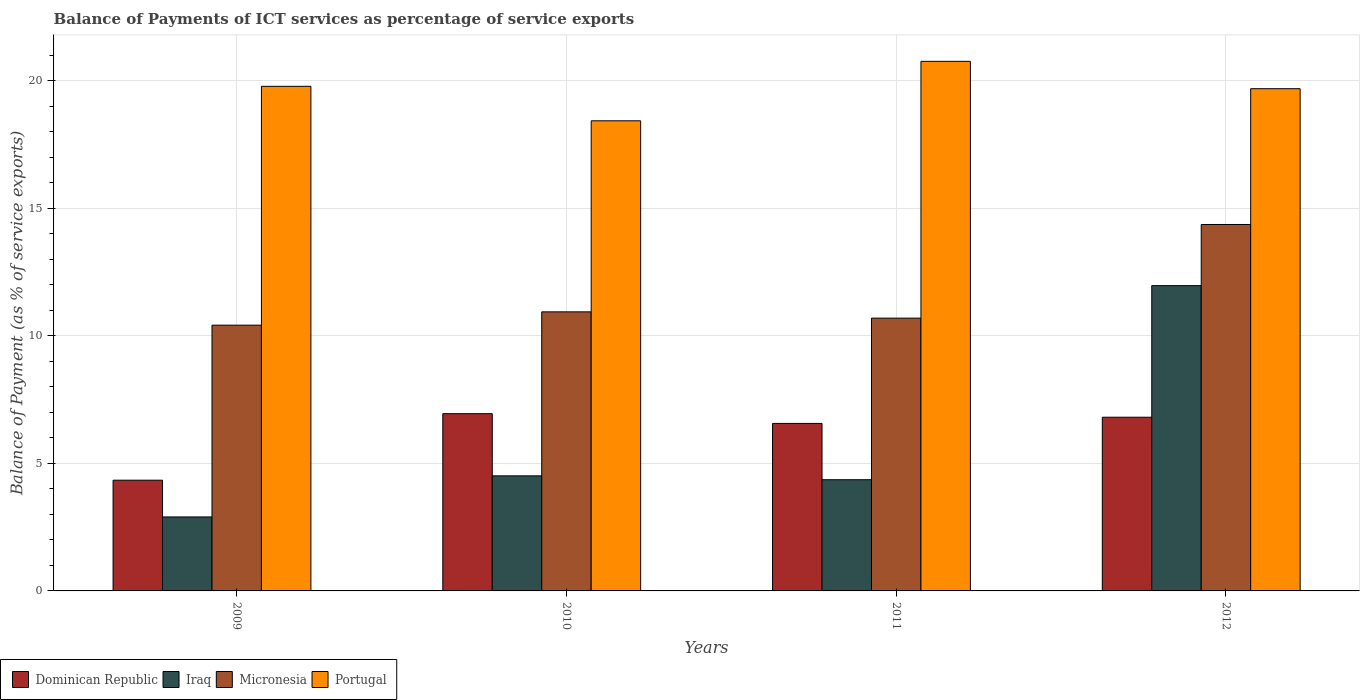How many groups of bars are there?
Offer a terse response. 4. How many bars are there on the 1st tick from the right?
Your answer should be very brief. 4. What is the label of the 4th group of bars from the left?
Make the answer very short. 2012. In how many cases, is the number of bars for a given year not equal to the number of legend labels?
Your response must be concise. 0. What is the balance of payments of ICT services in Iraq in 2012?
Provide a short and direct response. 11.97. Across all years, what is the maximum balance of payments of ICT services in Portugal?
Offer a terse response. 20.76. Across all years, what is the minimum balance of payments of ICT services in Dominican Republic?
Provide a short and direct response. 4.34. In which year was the balance of payments of ICT services in Portugal maximum?
Your response must be concise. 2011. In which year was the balance of payments of ICT services in Micronesia minimum?
Offer a very short reply. 2009. What is the total balance of payments of ICT services in Portugal in the graph?
Your answer should be very brief. 78.65. What is the difference between the balance of payments of ICT services in Portugal in 2009 and that in 2012?
Make the answer very short. 0.09. What is the difference between the balance of payments of ICT services in Micronesia in 2011 and the balance of payments of ICT services in Dominican Republic in 2009?
Provide a succinct answer. 6.35. What is the average balance of payments of ICT services in Portugal per year?
Give a very brief answer. 19.66. In the year 2009, what is the difference between the balance of payments of ICT services in Dominican Republic and balance of payments of ICT services in Portugal?
Offer a very short reply. -15.44. What is the ratio of the balance of payments of ICT services in Dominican Republic in 2009 to that in 2010?
Ensure brevity in your answer.  0.62. Is the difference between the balance of payments of ICT services in Dominican Republic in 2009 and 2012 greater than the difference between the balance of payments of ICT services in Portugal in 2009 and 2012?
Your answer should be very brief. No. What is the difference between the highest and the second highest balance of payments of ICT services in Portugal?
Your answer should be compact. 0.98. What is the difference between the highest and the lowest balance of payments of ICT services in Iraq?
Give a very brief answer. 9.07. In how many years, is the balance of payments of ICT services in Dominican Republic greater than the average balance of payments of ICT services in Dominican Republic taken over all years?
Keep it short and to the point. 3. Is it the case that in every year, the sum of the balance of payments of ICT services in Portugal and balance of payments of ICT services in Dominican Republic is greater than the sum of balance of payments of ICT services in Micronesia and balance of payments of ICT services in Iraq?
Provide a short and direct response. No. What does the 3rd bar from the left in 2011 represents?
Provide a short and direct response. Micronesia. What does the 2nd bar from the right in 2009 represents?
Provide a succinct answer. Micronesia. Is it the case that in every year, the sum of the balance of payments of ICT services in Portugal and balance of payments of ICT services in Dominican Republic is greater than the balance of payments of ICT services in Micronesia?
Offer a very short reply. Yes. How many years are there in the graph?
Provide a short and direct response. 4. Does the graph contain any zero values?
Make the answer very short. No. What is the title of the graph?
Offer a terse response. Balance of Payments of ICT services as percentage of service exports. What is the label or title of the Y-axis?
Provide a succinct answer. Balance of Payment (as % of service exports). What is the Balance of Payment (as % of service exports) of Dominican Republic in 2009?
Your answer should be very brief. 4.34. What is the Balance of Payment (as % of service exports) in Iraq in 2009?
Provide a succinct answer. 2.9. What is the Balance of Payment (as % of service exports) of Micronesia in 2009?
Offer a very short reply. 10.42. What is the Balance of Payment (as % of service exports) in Portugal in 2009?
Your response must be concise. 19.78. What is the Balance of Payment (as % of service exports) in Dominican Republic in 2010?
Your response must be concise. 6.95. What is the Balance of Payment (as % of service exports) of Iraq in 2010?
Your answer should be very brief. 4.51. What is the Balance of Payment (as % of service exports) in Micronesia in 2010?
Make the answer very short. 10.94. What is the Balance of Payment (as % of service exports) in Portugal in 2010?
Offer a very short reply. 18.43. What is the Balance of Payment (as % of service exports) in Dominican Republic in 2011?
Your answer should be very brief. 6.57. What is the Balance of Payment (as % of service exports) in Iraq in 2011?
Make the answer very short. 4.36. What is the Balance of Payment (as % of service exports) of Micronesia in 2011?
Ensure brevity in your answer.  10.69. What is the Balance of Payment (as % of service exports) of Portugal in 2011?
Make the answer very short. 20.76. What is the Balance of Payment (as % of service exports) of Dominican Republic in 2012?
Keep it short and to the point. 6.81. What is the Balance of Payment (as % of service exports) of Iraq in 2012?
Offer a terse response. 11.97. What is the Balance of Payment (as % of service exports) of Micronesia in 2012?
Provide a succinct answer. 14.36. What is the Balance of Payment (as % of service exports) of Portugal in 2012?
Keep it short and to the point. 19.68. Across all years, what is the maximum Balance of Payment (as % of service exports) in Dominican Republic?
Your answer should be compact. 6.95. Across all years, what is the maximum Balance of Payment (as % of service exports) in Iraq?
Your response must be concise. 11.97. Across all years, what is the maximum Balance of Payment (as % of service exports) in Micronesia?
Ensure brevity in your answer.  14.36. Across all years, what is the maximum Balance of Payment (as % of service exports) of Portugal?
Give a very brief answer. 20.76. Across all years, what is the minimum Balance of Payment (as % of service exports) in Dominican Republic?
Ensure brevity in your answer.  4.34. Across all years, what is the minimum Balance of Payment (as % of service exports) in Iraq?
Your response must be concise. 2.9. Across all years, what is the minimum Balance of Payment (as % of service exports) of Micronesia?
Offer a terse response. 10.42. Across all years, what is the minimum Balance of Payment (as % of service exports) in Portugal?
Provide a short and direct response. 18.43. What is the total Balance of Payment (as % of service exports) of Dominican Republic in the graph?
Offer a very short reply. 24.66. What is the total Balance of Payment (as % of service exports) of Iraq in the graph?
Offer a very short reply. 23.73. What is the total Balance of Payment (as % of service exports) in Micronesia in the graph?
Keep it short and to the point. 46.41. What is the total Balance of Payment (as % of service exports) of Portugal in the graph?
Your answer should be compact. 78.65. What is the difference between the Balance of Payment (as % of service exports) in Dominican Republic in 2009 and that in 2010?
Your answer should be compact. -2.61. What is the difference between the Balance of Payment (as % of service exports) in Iraq in 2009 and that in 2010?
Your answer should be compact. -1.61. What is the difference between the Balance of Payment (as % of service exports) in Micronesia in 2009 and that in 2010?
Provide a short and direct response. -0.52. What is the difference between the Balance of Payment (as % of service exports) of Portugal in 2009 and that in 2010?
Your answer should be compact. 1.35. What is the difference between the Balance of Payment (as % of service exports) of Dominican Republic in 2009 and that in 2011?
Your answer should be compact. -2.23. What is the difference between the Balance of Payment (as % of service exports) in Iraq in 2009 and that in 2011?
Your response must be concise. -1.46. What is the difference between the Balance of Payment (as % of service exports) in Micronesia in 2009 and that in 2011?
Give a very brief answer. -0.28. What is the difference between the Balance of Payment (as % of service exports) in Portugal in 2009 and that in 2011?
Your response must be concise. -0.98. What is the difference between the Balance of Payment (as % of service exports) in Dominican Republic in 2009 and that in 2012?
Ensure brevity in your answer.  -2.47. What is the difference between the Balance of Payment (as % of service exports) in Iraq in 2009 and that in 2012?
Give a very brief answer. -9.07. What is the difference between the Balance of Payment (as % of service exports) of Micronesia in 2009 and that in 2012?
Provide a short and direct response. -3.95. What is the difference between the Balance of Payment (as % of service exports) of Portugal in 2009 and that in 2012?
Offer a very short reply. 0.09. What is the difference between the Balance of Payment (as % of service exports) of Dominican Republic in 2010 and that in 2011?
Provide a short and direct response. 0.38. What is the difference between the Balance of Payment (as % of service exports) in Iraq in 2010 and that in 2011?
Provide a short and direct response. 0.15. What is the difference between the Balance of Payment (as % of service exports) in Micronesia in 2010 and that in 2011?
Offer a very short reply. 0.25. What is the difference between the Balance of Payment (as % of service exports) in Portugal in 2010 and that in 2011?
Provide a short and direct response. -2.33. What is the difference between the Balance of Payment (as % of service exports) of Dominican Republic in 2010 and that in 2012?
Keep it short and to the point. 0.14. What is the difference between the Balance of Payment (as % of service exports) in Iraq in 2010 and that in 2012?
Provide a succinct answer. -7.46. What is the difference between the Balance of Payment (as % of service exports) of Micronesia in 2010 and that in 2012?
Keep it short and to the point. -3.42. What is the difference between the Balance of Payment (as % of service exports) of Portugal in 2010 and that in 2012?
Offer a terse response. -1.26. What is the difference between the Balance of Payment (as % of service exports) of Dominican Republic in 2011 and that in 2012?
Give a very brief answer. -0.24. What is the difference between the Balance of Payment (as % of service exports) in Iraq in 2011 and that in 2012?
Make the answer very short. -7.61. What is the difference between the Balance of Payment (as % of service exports) in Micronesia in 2011 and that in 2012?
Offer a terse response. -3.67. What is the difference between the Balance of Payment (as % of service exports) in Portugal in 2011 and that in 2012?
Provide a short and direct response. 1.07. What is the difference between the Balance of Payment (as % of service exports) in Dominican Republic in 2009 and the Balance of Payment (as % of service exports) in Iraq in 2010?
Keep it short and to the point. -0.17. What is the difference between the Balance of Payment (as % of service exports) of Dominican Republic in 2009 and the Balance of Payment (as % of service exports) of Micronesia in 2010?
Provide a succinct answer. -6.6. What is the difference between the Balance of Payment (as % of service exports) of Dominican Republic in 2009 and the Balance of Payment (as % of service exports) of Portugal in 2010?
Your response must be concise. -14.09. What is the difference between the Balance of Payment (as % of service exports) in Iraq in 2009 and the Balance of Payment (as % of service exports) in Micronesia in 2010?
Offer a very short reply. -8.04. What is the difference between the Balance of Payment (as % of service exports) in Iraq in 2009 and the Balance of Payment (as % of service exports) in Portugal in 2010?
Ensure brevity in your answer.  -15.53. What is the difference between the Balance of Payment (as % of service exports) of Micronesia in 2009 and the Balance of Payment (as % of service exports) of Portugal in 2010?
Provide a succinct answer. -8.01. What is the difference between the Balance of Payment (as % of service exports) in Dominican Republic in 2009 and the Balance of Payment (as % of service exports) in Iraq in 2011?
Provide a short and direct response. -0.02. What is the difference between the Balance of Payment (as % of service exports) in Dominican Republic in 2009 and the Balance of Payment (as % of service exports) in Micronesia in 2011?
Offer a terse response. -6.35. What is the difference between the Balance of Payment (as % of service exports) of Dominican Republic in 2009 and the Balance of Payment (as % of service exports) of Portugal in 2011?
Your response must be concise. -16.42. What is the difference between the Balance of Payment (as % of service exports) of Iraq in 2009 and the Balance of Payment (as % of service exports) of Micronesia in 2011?
Your response must be concise. -7.79. What is the difference between the Balance of Payment (as % of service exports) in Iraq in 2009 and the Balance of Payment (as % of service exports) in Portugal in 2011?
Your response must be concise. -17.86. What is the difference between the Balance of Payment (as % of service exports) of Micronesia in 2009 and the Balance of Payment (as % of service exports) of Portugal in 2011?
Provide a succinct answer. -10.34. What is the difference between the Balance of Payment (as % of service exports) of Dominican Republic in 2009 and the Balance of Payment (as % of service exports) of Iraq in 2012?
Your answer should be compact. -7.63. What is the difference between the Balance of Payment (as % of service exports) of Dominican Republic in 2009 and the Balance of Payment (as % of service exports) of Micronesia in 2012?
Offer a terse response. -10.02. What is the difference between the Balance of Payment (as % of service exports) of Dominican Republic in 2009 and the Balance of Payment (as % of service exports) of Portugal in 2012?
Make the answer very short. -15.34. What is the difference between the Balance of Payment (as % of service exports) of Iraq in 2009 and the Balance of Payment (as % of service exports) of Micronesia in 2012?
Your answer should be very brief. -11.46. What is the difference between the Balance of Payment (as % of service exports) in Iraq in 2009 and the Balance of Payment (as % of service exports) in Portugal in 2012?
Your answer should be very brief. -16.79. What is the difference between the Balance of Payment (as % of service exports) of Micronesia in 2009 and the Balance of Payment (as % of service exports) of Portugal in 2012?
Give a very brief answer. -9.27. What is the difference between the Balance of Payment (as % of service exports) in Dominican Republic in 2010 and the Balance of Payment (as % of service exports) in Iraq in 2011?
Offer a terse response. 2.59. What is the difference between the Balance of Payment (as % of service exports) of Dominican Republic in 2010 and the Balance of Payment (as % of service exports) of Micronesia in 2011?
Your answer should be compact. -3.74. What is the difference between the Balance of Payment (as % of service exports) of Dominican Republic in 2010 and the Balance of Payment (as % of service exports) of Portugal in 2011?
Your answer should be very brief. -13.81. What is the difference between the Balance of Payment (as % of service exports) of Iraq in 2010 and the Balance of Payment (as % of service exports) of Micronesia in 2011?
Provide a succinct answer. -6.18. What is the difference between the Balance of Payment (as % of service exports) in Iraq in 2010 and the Balance of Payment (as % of service exports) in Portugal in 2011?
Ensure brevity in your answer.  -16.25. What is the difference between the Balance of Payment (as % of service exports) in Micronesia in 2010 and the Balance of Payment (as % of service exports) in Portugal in 2011?
Your answer should be compact. -9.82. What is the difference between the Balance of Payment (as % of service exports) of Dominican Republic in 2010 and the Balance of Payment (as % of service exports) of Iraq in 2012?
Offer a terse response. -5.02. What is the difference between the Balance of Payment (as % of service exports) in Dominican Republic in 2010 and the Balance of Payment (as % of service exports) in Micronesia in 2012?
Your response must be concise. -7.42. What is the difference between the Balance of Payment (as % of service exports) in Dominican Republic in 2010 and the Balance of Payment (as % of service exports) in Portugal in 2012?
Your answer should be very brief. -12.74. What is the difference between the Balance of Payment (as % of service exports) of Iraq in 2010 and the Balance of Payment (as % of service exports) of Micronesia in 2012?
Your response must be concise. -9.85. What is the difference between the Balance of Payment (as % of service exports) in Iraq in 2010 and the Balance of Payment (as % of service exports) in Portugal in 2012?
Your answer should be very brief. -15.17. What is the difference between the Balance of Payment (as % of service exports) in Micronesia in 2010 and the Balance of Payment (as % of service exports) in Portugal in 2012?
Provide a short and direct response. -8.75. What is the difference between the Balance of Payment (as % of service exports) in Dominican Republic in 2011 and the Balance of Payment (as % of service exports) in Iraq in 2012?
Offer a terse response. -5.4. What is the difference between the Balance of Payment (as % of service exports) of Dominican Republic in 2011 and the Balance of Payment (as % of service exports) of Micronesia in 2012?
Offer a very short reply. -7.8. What is the difference between the Balance of Payment (as % of service exports) of Dominican Republic in 2011 and the Balance of Payment (as % of service exports) of Portugal in 2012?
Your response must be concise. -13.12. What is the difference between the Balance of Payment (as % of service exports) of Iraq in 2011 and the Balance of Payment (as % of service exports) of Micronesia in 2012?
Your answer should be very brief. -10. What is the difference between the Balance of Payment (as % of service exports) in Iraq in 2011 and the Balance of Payment (as % of service exports) in Portugal in 2012?
Provide a succinct answer. -15.33. What is the difference between the Balance of Payment (as % of service exports) in Micronesia in 2011 and the Balance of Payment (as % of service exports) in Portugal in 2012?
Make the answer very short. -8.99. What is the average Balance of Payment (as % of service exports) of Dominican Republic per year?
Provide a succinct answer. 6.17. What is the average Balance of Payment (as % of service exports) of Iraq per year?
Your answer should be very brief. 5.93. What is the average Balance of Payment (as % of service exports) of Micronesia per year?
Offer a very short reply. 11.6. What is the average Balance of Payment (as % of service exports) in Portugal per year?
Provide a short and direct response. 19.66. In the year 2009, what is the difference between the Balance of Payment (as % of service exports) in Dominican Republic and Balance of Payment (as % of service exports) in Iraq?
Keep it short and to the point. 1.44. In the year 2009, what is the difference between the Balance of Payment (as % of service exports) of Dominican Republic and Balance of Payment (as % of service exports) of Micronesia?
Make the answer very short. -6.08. In the year 2009, what is the difference between the Balance of Payment (as % of service exports) in Dominican Republic and Balance of Payment (as % of service exports) in Portugal?
Give a very brief answer. -15.44. In the year 2009, what is the difference between the Balance of Payment (as % of service exports) of Iraq and Balance of Payment (as % of service exports) of Micronesia?
Ensure brevity in your answer.  -7.52. In the year 2009, what is the difference between the Balance of Payment (as % of service exports) of Iraq and Balance of Payment (as % of service exports) of Portugal?
Give a very brief answer. -16.88. In the year 2009, what is the difference between the Balance of Payment (as % of service exports) of Micronesia and Balance of Payment (as % of service exports) of Portugal?
Ensure brevity in your answer.  -9.36. In the year 2010, what is the difference between the Balance of Payment (as % of service exports) in Dominican Republic and Balance of Payment (as % of service exports) in Iraq?
Provide a succinct answer. 2.44. In the year 2010, what is the difference between the Balance of Payment (as % of service exports) of Dominican Republic and Balance of Payment (as % of service exports) of Micronesia?
Make the answer very short. -3.99. In the year 2010, what is the difference between the Balance of Payment (as % of service exports) of Dominican Republic and Balance of Payment (as % of service exports) of Portugal?
Offer a very short reply. -11.48. In the year 2010, what is the difference between the Balance of Payment (as % of service exports) of Iraq and Balance of Payment (as % of service exports) of Micronesia?
Your answer should be compact. -6.43. In the year 2010, what is the difference between the Balance of Payment (as % of service exports) of Iraq and Balance of Payment (as % of service exports) of Portugal?
Your answer should be compact. -13.92. In the year 2010, what is the difference between the Balance of Payment (as % of service exports) in Micronesia and Balance of Payment (as % of service exports) in Portugal?
Give a very brief answer. -7.49. In the year 2011, what is the difference between the Balance of Payment (as % of service exports) in Dominican Republic and Balance of Payment (as % of service exports) in Iraq?
Make the answer very short. 2.21. In the year 2011, what is the difference between the Balance of Payment (as % of service exports) of Dominican Republic and Balance of Payment (as % of service exports) of Micronesia?
Provide a succinct answer. -4.13. In the year 2011, what is the difference between the Balance of Payment (as % of service exports) in Dominican Republic and Balance of Payment (as % of service exports) in Portugal?
Ensure brevity in your answer.  -14.19. In the year 2011, what is the difference between the Balance of Payment (as % of service exports) of Iraq and Balance of Payment (as % of service exports) of Micronesia?
Offer a very short reply. -6.33. In the year 2011, what is the difference between the Balance of Payment (as % of service exports) of Iraq and Balance of Payment (as % of service exports) of Portugal?
Give a very brief answer. -16.4. In the year 2011, what is the difference between the Balance of Payment (as % of service exports) in Micronesia and Balance of Payment (as % of service exports) in Portugal?
Your response must be concise. -10.06. In the year 2012, what is the difference between the Balance of Payment (as % of service exports) in Dominican Republic and Balance of Payment (as % of service exports) in Iraq?
Make the answer very short. -5.16. In the year 2012, what is the difference between the Balance of Payment (as % of service exports) in Dominican Republic and Balance of Payment (as % of service exports) in Micronesia?
Your answer should be very brief. -7.55. In the year 2012, what is the difference between the Balance of Payment (as % of service exports) of Dominican Republic and Balance of Payment (as % of service exports) of Portugal?
Your answer should be compact. -12.88. In the year 2012, what is the difference between the Balance of Payment (as % of service exports) of Iraq and Balance of Payment (as % of service exports) of Micronesia?
Provide a short and direct response. -2.4. In the year 2012, what is the difference between the Balance of Payment (as % of service exports) in Iraq and Balance of Payment (as % of service exports) in Portugal?
Ensure brevity in your answer.  -7.72. In the year 2012, what is the difference between the Balance of Payment (as % of service exports) of Micronesia and Balance of Payment (as % of service exports) of Portugal?
Your answer should be compact. -5.32. What is the ratio of the Balance of Payment (as % of service exports) in Dominican Republic in 2009 to that in 2010?
Your answer should be compact. 0.62. What is the ratio of the Balance of Payment (as % of service exports) in Iraq in 2009 to that in 2010?
Your response must be concise. 0.64. What is the ratio of the Balance of Payment (as % of service exports) of Micronesia in 2009 to that in 2010?
Your answer should be very brief. 0.95. What is the ratio of the Balance of Payment (as % of service exports) of Portugal in 2009 to that in 2010?
Your answer should be compact. 1.07. What is the ratio of the Balance of Payment (as % of service exports) of Dominican Republic in 2009 to that in 2011?
Provide a short and direct response. 0.66. What is the ratio of the Balance of Payment (as % of service exports) in Iraq in 2009 to that in 2011?
Provide a succinct answer. 0.67. What is the ratio of the Balance of Payment (as % of service exports) of Micronesia in 2009 to that in 2011?
Offer a terse response. 0.97. What is the ratio of the Balance of Payment (as % of service exports) of Portugal in 2009 to that in 2011?
Offer a very short reply. 0.95. What is the ratio of the Balance of Payment (as % of service exports) of Dominican Republic in 2009 to that in 2012?
Your answer should be very brief. 0.64. What is the ratio of the Balance of Payment (as % of service exports) of Iraq in 2009 to that in 2012?
Offer a very short reply. 0.24. What is the ratio of the Balance of Payment (as % of service exports) of Micronesia in 2009 to that in 2012?
Give a very brief answer. 0.73. What is the ratio of the Balance of Payment (as % of service exports) in Dominican Republic in 2010 to that in 2011?
Give a very brief answer. 1.06. What is the ratio of the Balance of Payment (as % of service exports) of Iraq in 2010 to that in 2011?
Offer a very short reply. 1.03. What is the ratio of the Balance of Payment (as % of service exports) in Micronesia in 2010 to that in 2011?
Your answer should be compact. 1.02. What is the ratio of the Balance of Payment (as % of service exports) in Portugal in 2010 to that in 2011?
Your response must be concise. 0.89. What is the ratio of the Balance of Payment (as % of service exports) in Dominican Republic in 2010 to that in 2012?
Ensure brevity in your answer.  1.02. What is the ratio of the Balance of Payment (as % of service exports) in Iraq in 2010 to that in 2012?
Your answer should be compact. 0.38. What is the ratio of the Balance of Payment (as % of service exports) in Micronesia in 2010 to that in 2012?
Offer a terse response. 0.76. What is the ratio of the Balance of Payment (as % of service exports) of Portugal in 2010 to that in 2012?
Your answer should be very brief. 0.94. What is the ratio of the Balance of Payment (as % of service exports) in Dominican Republic in 2011 to that in 2012?
Your response must be concise. 0.96. What is the ratio of the Balance of Payment (as % of service exports) of Iraq in 2011 to that in 2012?
Provide a succinct answer. 0.36. What is the ratio of the Balance of Payment (as % of service exports) in Micronesia in 2011 to that in 2012?
Your response must be concise. 0.74. What is the ratio of the Balance of Payment (as % of service exports) of Portugal in 2011 to that in 2012?
Offer a terse response. 1.05. What is the difference between the highest and the second highest Balance of Payment (as % of service exports) of Dominican Republic?
Your response must be concise. 0.14. What is the difference between the highest and the second highest Balance of Payment (as % of service exports) of Iraq?
Ensure brevity in your answer.  7.46. What is the difference between the highest and the second highest Balance of Payment (as % of service exports) of Micronesia?
Provide a short and direct response. 3.42. What is the difference between the highest and the second highest Balance of Payment (as % of service exports) of Portugal?
Your answer should be very brief. 0.98. What is the difference between the highest and the lowest Balance of Payment (as % of service exports) of Dominican Republic?
Offer a terse response. 2.61. What is the difference between the highest and the lowest Balance of Payment (as % of service exports) in Iraq?
Offer a very short reply. 9.07. What is the difference between the highest and the lowest Balance of Payment (as % of service exports) in Micronesia?
Give a very brief answer. 3.95. What is the difference between the highest and the lowest Balance of Payment (as % of service exports) in Portugal?
Your answer should be very brief. 2.33. 